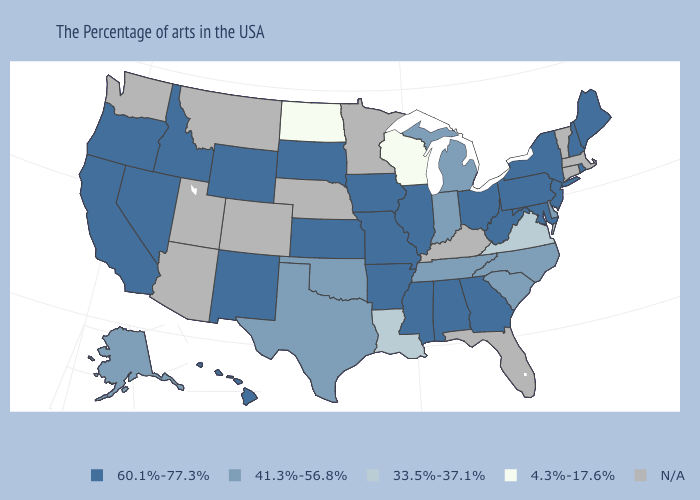Among the states that border Connecticut , which have the lowest value?
Write a very short answer. Rhode Island, New York. What is the lowest value in the USA?
Be succinct. 4.3%-17.6%. What is the lowest value in states that border Pennsylvania?
Be succinct. 41.3%-56.8%. Among the states that border Maine , which have the lowest value?
Answer briefly. New Hampshire. Which states have the lowest value in the USA?
Write a very short answer. Wisconsin, North Dakota. What is the value of Virginia?
Answer briefly. 33.5%-37.1%. Which states have the lowest value in the South?
Write a very short answer. Virginia, Louisiana. Name the states that have a value in the range 33.5%-37.1%?
Give a very brief answer. Virginia, Louisiana. What is the lowest value in the USA?
Give a very brief answer. 4.3%-17.6%. Name the states that have a value in the range 4.3%-17.6%?
Be succinct. Wisconsin, North Dakota. Among the states that border Texas , which have the lowest value?
Be succinct. Louisiana. How many symbols are there in the legend?
Quick response, please. 5. Which states have the lowest value in the USA?
Write a very short answer. Wisconsin, North Dakota. 